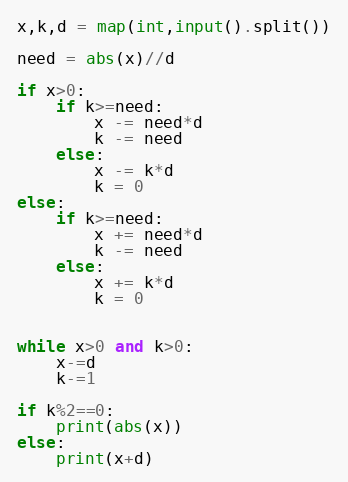<code> <loc_0><loc_0><loc_500><loc_500><_Python_>x,k,d = map(int,input().split())

need = abs(x)//d

if x>0:
    if k>=need:
        x -= need*d
        k -= need
    else:
        x -= k*d
        k = 0
else:
    if k>=need:
        x += need*d
        k -= need
    else:
        x += k*d
        k = 0
    

while x>0 and k>0:
    x-=d
    k-=1

if k%2==0:
    print(abs(x))
else:
    print(x+d)
</code> 